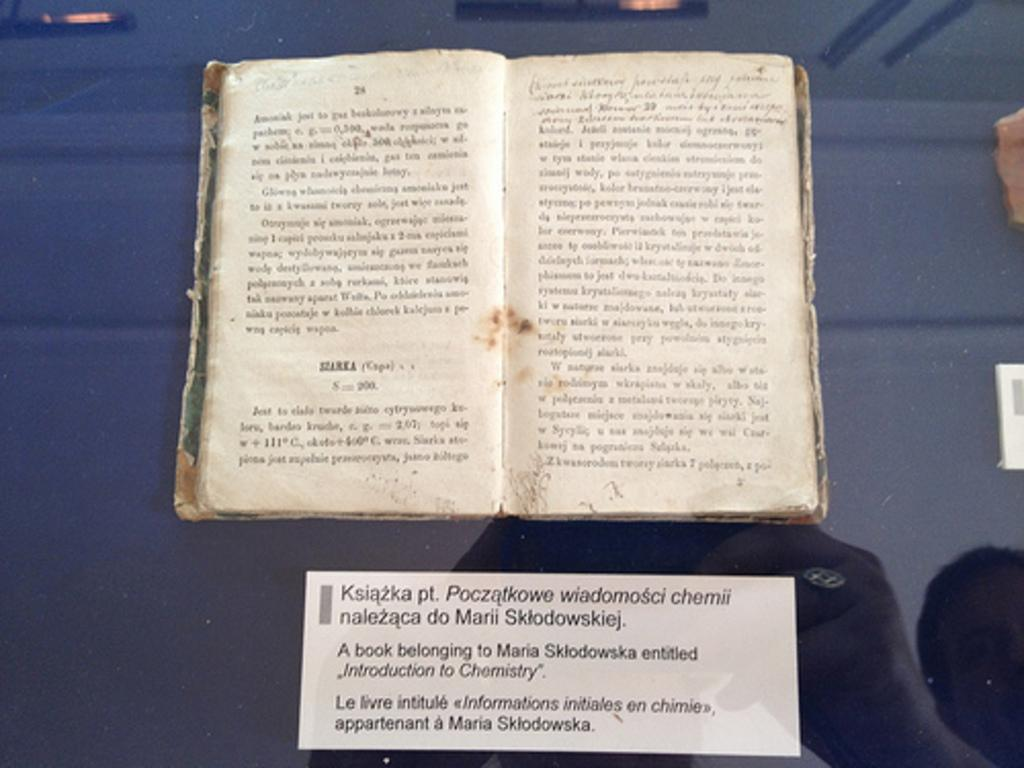<image>
Give a short and clear explanation of the subsequent image. A book on display with a card stating it was owned by Maria Sklofowska. 